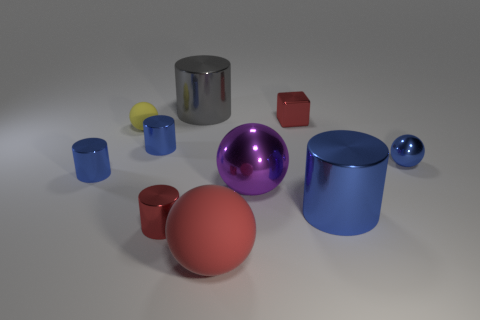Subtract all blue cylinders. How many were subtracted if there are1blue cylinders left? 2 Subtract all green blocks. How many blue cylinders are left? 3 Subtract 1 cylinders. How many cylinders are left? 4 Subtract all gray cylinders. How many cylinders are left? 4 Subtract all gray shiny cylinders. How many cylinders are left? 4 Subtract all yellow cylinders. Subtract all brown balls. How many cylinders are left? 5 Subtract all blocks. How many objects are left? 9 Add 6 brown cylinders. How many brown cylinders exist? 6 Subtract 0 gray spheres. How many objects are left? 10 Subtract all purple metallic balls. Subtract all large cylinders. How many objects are left? 7 